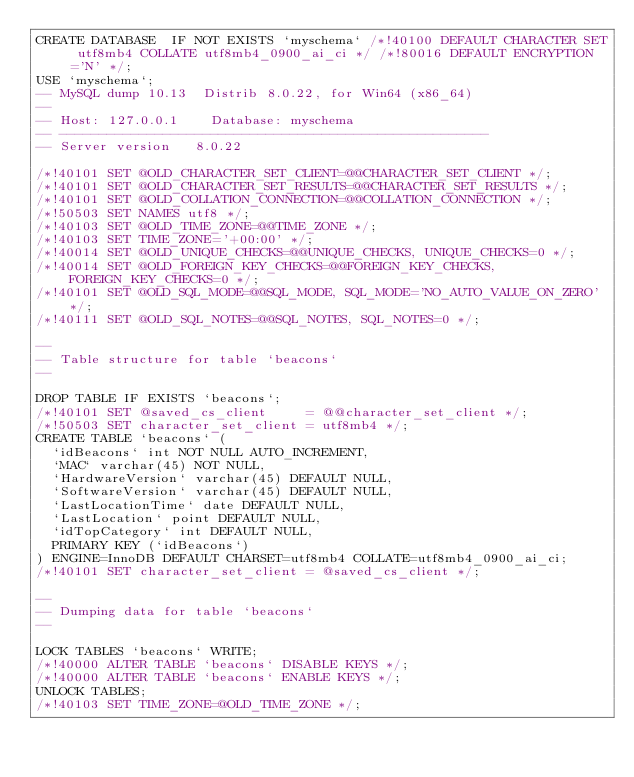Convert code to text. <code><loc_0><loc_0><loc_500><loc_500><_SQL_>CREATE DATABASE  IF NOT EXISTS `myschema` /*!40100 DEFAULT CHARACTER SET utf8mb4 COLLATE utf8mb4_0900_ai_ci */ /*!80016 DEFAULT ENCRYPTION='N' */;
USE `myschema`;
-- MySQL dump 10.13  Distrib 8.0.22, for Win64 (x86_64)
--
-- Host: 127.0.0.1    Database: myschema
-- ------------------------------------------------------
-- Server version	8.0.22

/*!40101 SET @OLD_CHARACTER_SET_CLIENT=@@CHARACTER_SET_CLIENT */;
/*!40101 SET @OLD_CHARACTER_SET_RESULTS=@@CHARACTER_SET_RESULTS */;
/*!40101 SET @OLD_COLLATION_CONNECTION=@@COLLATION_CONNECTION */;
/*!50503 SET NAMES utf8 */;
/*!40103 SET @OLD_TIME_ZONE=@@TIME_ZONE */;
/*!40103 SET TIME_ZONE='+00:00' */;
/*!40014 SET @OLD_UNIQUE_CHECKS=@@UNIQUE_CHECKS, UNIQUE_CHECKS=0 */;
/*!40014 SET @OLD_FOREIGN_KEY_CHECKS=@@FOREIGN_KEY_CHECKS, FOREIGN_KEY_CHECKS=0 */;
/*!40101 SET @OLD_SQL_MODE=@@SQL_MODE, SQL_MODE='NO_AUTO_VALUE_ON_ZERO' */;
/*!40111 SET @OLD_SQL_NOTES=@@SQL_NOTES, SQL_NOTES=0 */;

--
-- Table structure for table `beacons`
--

DROP TABLE IF EXISTS `beacons`;
/*!40101 SET @saved_cs_client     = @@character_set_client */;
/*!50503 SET character_set_client = utf8mb4 */;
CREATE TABLE `beacons` (
  `idBeacons` int NOT NULL AUTO_INCREMENT,
  `MAC` varchar(45) NOT NULL,
  `HardwareVersion` varchar(45) DEFAULT NULL,
  `SoftwareVersion` varchar(45) DEFAULT NULL,
  `LastLocationTime` date DEFAULT NULL,
  `LastLocation` point DEFAULT NULL,
  `idTopCategory` int DEFAULT NULL,
  PRIMARY KEY (`idBeacons`)
) ENGINE=InnoDB DEFAULT CHARSET=utf8mb4 COLLATE=utf8mb4_0900_ai_ci;
/*!40101 SET character_set_client = @saved_cs_client */;

--
-- Dumping data for table `beacons`
--

LOCK TABLES `beacons` WRITE;
/*!40000 ALTER TABLE `beacons` DISABLE KEYS */;
/*!40000 ALTER TABLE `beacons` ENABLE KEYS */;
UNLOCK TABLES;
/*!40103 SET TIME_ZONE=@OLD_TIME_ZONE */;
</code> 